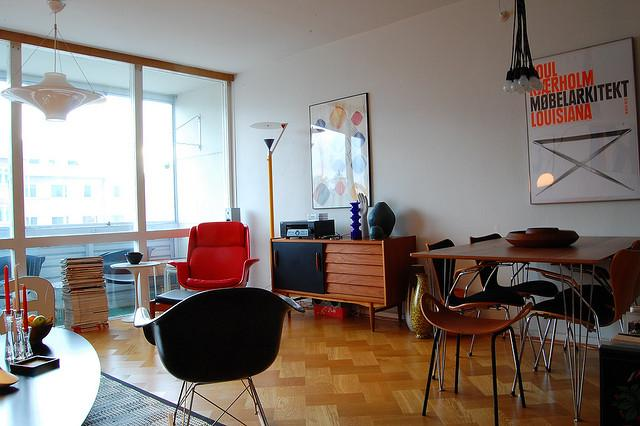What is next to the table on the left? chair 